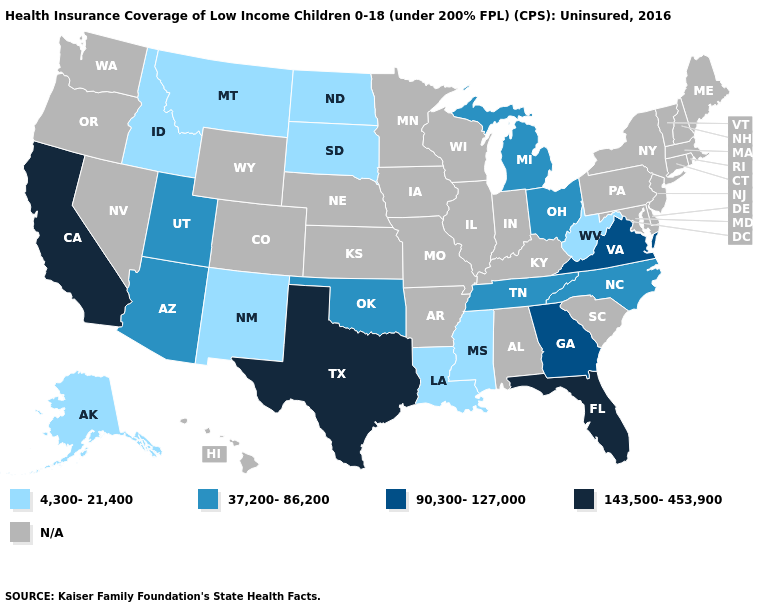What is the highest value in the USA?
Short answer required. 143,500-453,900. What is the value of Mississippi?
Concise answer only. 4,300-21,400. What is the value of Louisiana?
Give a very brief answer. 4,300-21,400. What is the value of Connecticut?
Short answer required. N/A. Which states have the lowest value in the USA?
Concise answer only. Alaska, Idaho, Louisiana, Mississippi, Montana, New Mexico, North Dakota, South Dakota, West Virginia. Is the legend a continuous bar?
Answer briefly. No. What is the value of South Dakota?
Answer briefly. 4,300-21,400. What is the value of North Dakota?
Write a very short answer. 4,300-21,400. What is the lowest value in the South?
Short answer required. 4,300-21,400. 